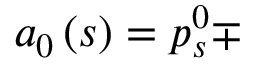Convert formula to latex. <formula><loc_0><loc_0><loc_500><loc_500>a _ { 0 } \left ( s \right ) = p _ { s } ^ { 0 } \mp</formula> 